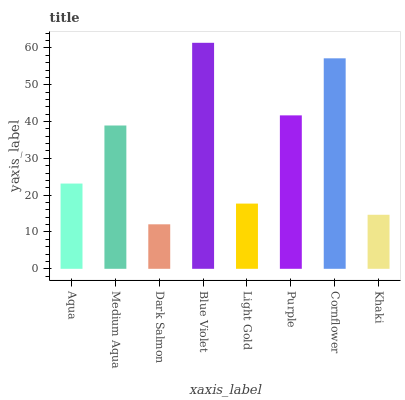Is Dark Salmon the minimum?
Answer yes or no. Yes. Is Blue Violet the maximum?
Answer yes or no. Yes. Is Medium Aqua the minimum?
Answer yes or no. No. Is Medium Aqua the maximum?
Answer yes or no. No. Is Medium Aqua greater than Aqua?
Answer yes or no. Yes. Is Aqua less than Medium Aqua?
Answer yes or no. Yes. Is Aqua greater than Medium Aqua?
Answer yes or no. No. Is Medium Aqua less than Aqua?
Answer yes or no. No. Is Medium Aqua the high median?
Answer yes or no. Yes. Is Aqua the low median?
Answer yes or no. Yes. Is Purple the high median?
Answer yes or no. No. Is Purple the low median?
Answer yes or no. No. 